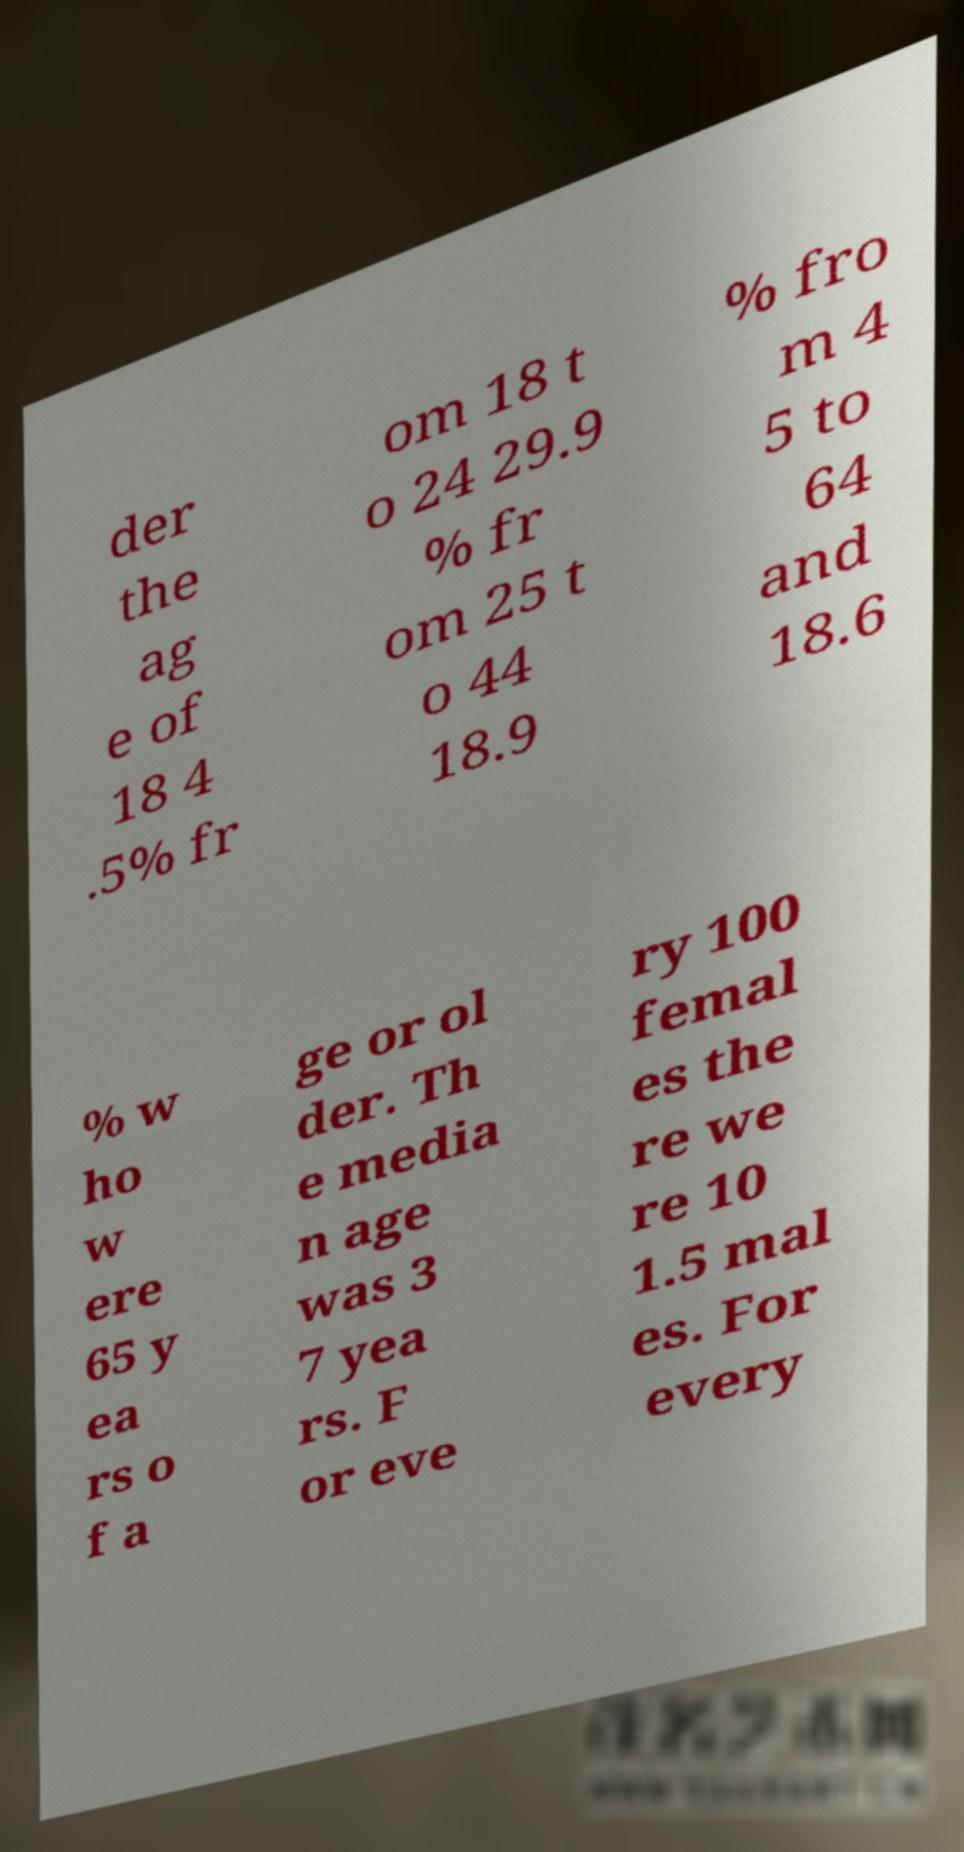Could you extract and type out the text from this image? der the ag e of 18 4 .5% fr om 18 t o 24 29.9 % fr om 25 t o 44 18.9 % fro m 4 5 to 64 and 18.6 % w ho w ere 65 y ea rs o f a ge or ol der. Th e media n age was 3 7 yea rs. F or eve ry 100 femal es the re we re 10 1.5 mal es. For every 